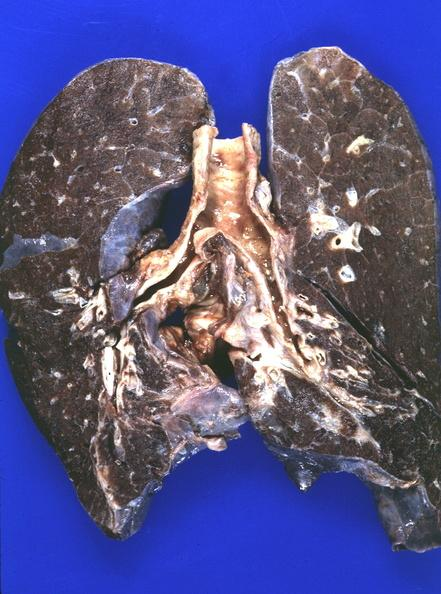s respiratory present?
Answer the question using a single word or phrase. Yes 